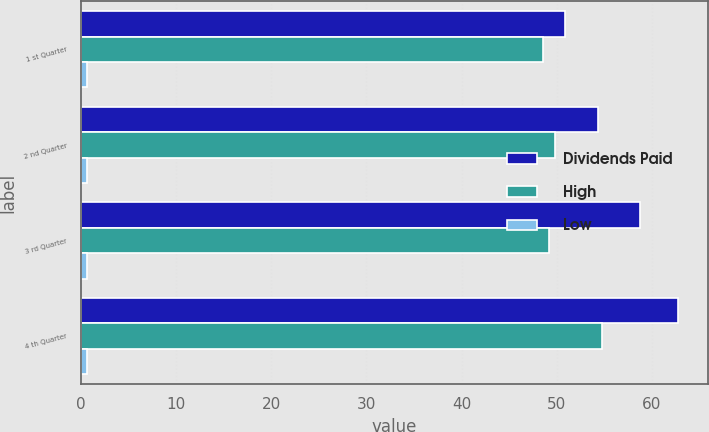Convert chart to OTSL. <chart><loc_0><loc_0><loc_500><loc_500><stacked_bar_chart><ecel><fcel>1 st Quarter<fcel>2 nd Quarter<fcel>3 rd Quarter<fcel>4 th Quarter<nl><fcel>Dividends Paid<fcel>50.9<fcel>54.36<fcel>58.79<fcel>62.74<nl><fcel>High<fcel>48.55<fcel>49.8<fcel>49.18<fcel>54.72<nl><fcel>Low<fcel>0.6<fcel>0.6<fcel>0.6<fcel>0.6<nl></chart> 